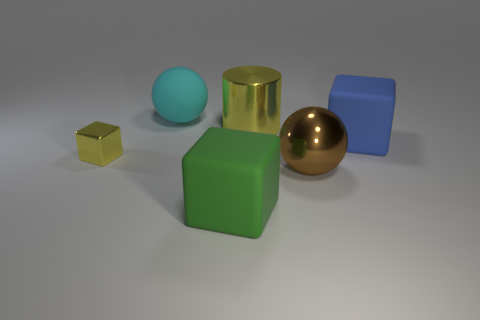Is there anything else that has the same shape as the big yellow thing?
Your response must be concise. No. What shape is the green matte object that is the same size as the matte ball?
Provide a succinct answer. Cube. Is there a small yellow shiny thing that has the same shape as the large green matte thing?
Your answer should be compact. Yes. What is the cyan ball made of?
Give a very brief answer. Rubber. Are there any brown shiny objects behind the cyan rubber object?
Your answer should be compact. No. How many cyan rubber things are in front of the big matte block behind the shiny cube?
Provide a succinct answer. 0. What material is the cyan sphere that is the same size as the green thing?
Ensure brevity in your answer.  Rubber. What number of other objects are there of the same material as the big cyan ball?
Your answer should be compact. 2. There is a large green rubber object; how many cyan things are in front of it?
Give a very brief answer. 0. What number of cubes are either big yellow metal objects or big cyan metal objects?
Give a very brief answer. 0. 